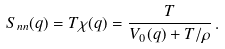Convert formula to latex. <formula><loc_0><loc_0><loc_500><loc_500>S _ { n n } ( { q } ) = T \chi ( { q } ) = \frac { T } { V _ { 0 } ( { q } ) + T / \rho } \, .</formula> 